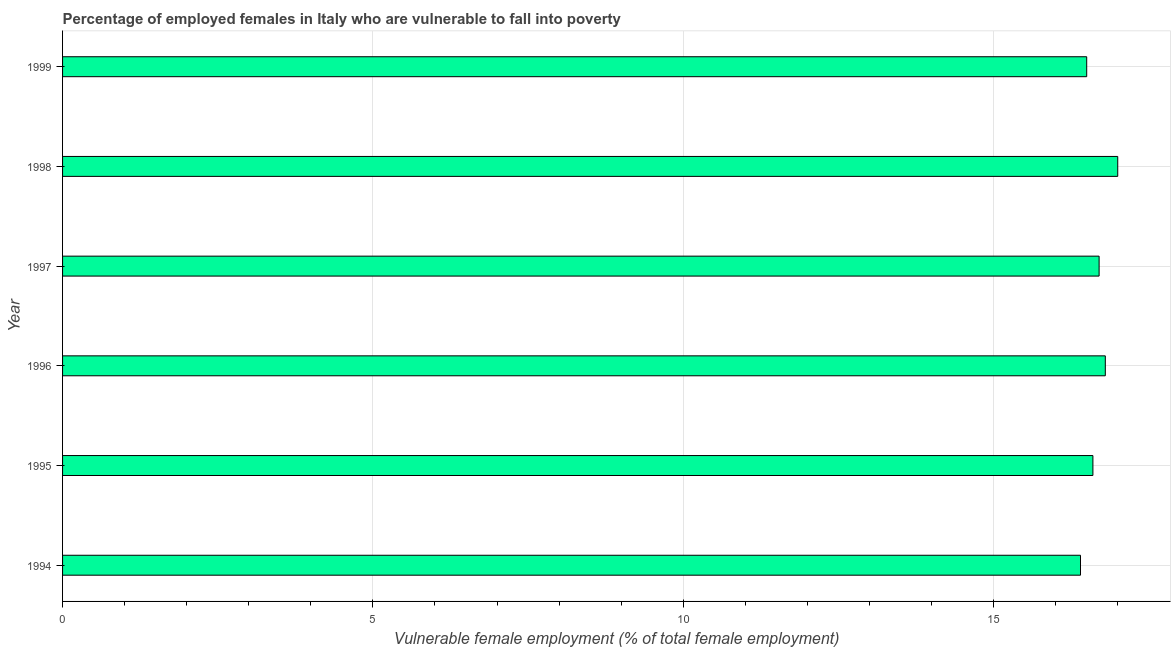What is the title of the graph?
Make the answer very short. Percentage of employed females in Italy who are vulnerable to fall into poverty. What is the label or title of the X-axis?
Your response must be concise. Vulnerable female employment (% of total female employment). What is the label or title of the Y-axis?
Your answer should be very brief. Year. What is the percentage of employed females who are vulnerable to fall into poverty in 1997?
Your answer should be compact. 16.7. Across all years, what is the maximum percentage of employed females who are vulnerable to fall into poverty?
Keep it short and to the point. 17. Across all years, what is the minimum percentage of employed females who are vulnerable to fall into poverty?
Your response must be concise. 16.4. What is the sum of the percentage of employed females who are vulnerable to fall into poverty?
Provide a succinct answer. 100. What is the average percentage of employed females who are vulnerable to fall into poverty per year?
Offer a terse response. 16.67. What is the median percentage of employed females who are vulnerable to fall into poverty?
Give a very brief answer. 16.65. In how many years, is the percentage of employed females who are vulnerable to fall into poverty greater than 12 %?
Provide a short and direct response. 6. Is the difference between the percentage of employed females who are vulnerable to fall into poverty in 1995 and 1999 greater than the difference between any two years?
Make the answer very short. No. What is the difference between the highest and the second highest percentage of employed females who are vulnerable to fall into poverty?
Offer a very short reply. 0.2. What is the difference between the highest and the lowest percentage of employed females who are vulnerable to fall into poverty?
Ensure brevity in your answer.  0.6. In how many years, is the percentage of employed females who are vulnerable to fall into poverty greater than the average percentage of employed females who are vulnerable to fall into poverty taken over all years?
Make the answer very short. 3. What is the difference between two consecutive major ticks on the X-axis?
Provide a short and direct response. 5. What is the Vulnerable female employment (% of total female employment) of 1994?
Offer a terse response. 16.4. What is the Vulnerable female employment (% of total female employment) in 1995?
Your answer should be very brief. 16.6. What is the Vulnerable female employment (% of total female employment) of 1996?
Make the answer very short. 16.8. What is the Vulnerable female employment (% of total female employment) in 1997?
Your response must be concise. 16.7. What is the Vulnerable female employment (% of total female employment) in 1998?
Offer a terse response. 17. What is the difference between the Vulnerable female employment (% of total female employment) in 1994 and 1995?
Provide a succinct answer. -0.2. What is the difference between the Vulnerable female employment (% of total female employment) in 1994 and 1997?
Provide a short and direct response. -0.3. What is the difference between the Vulnerable female employment (% of total female employment) in 1994 and 1998?
Your response must be concise. -0.6. What is the difference between the Vulnerable female employment (% of total female employment) in 1994 and 1999?
Provide a short and direct response. -0.1. What is the difference between the Vulnerable female employment (% of total female employment) in 1995 and 1997?
Make the answer very short. -0.1. What is the difference between the Vulnerable female employment (% of total female employment) in 1996 and 1999?
Provide a succinct answer. 0.3. What is the difference between the Vulnerable female employment (% of total female employment) in 1997 and 1999?
Offer a terse response. 0.2. What is the ratio of the Vulnerable female employment (% of total female employment) in 1994 to that in 1995?
Keep it short and to the point. 0.99. What is the ratio of the Vulnerable female employment (% of total female employment) in 1994 to that in 1996?
Your answer should be compact. 0.98. What is the ratio of the Vulnerable female employment (% of total female employment) in 1994 to that in 1999?
Offer a very short reply. 0.99. What is the ratio of the Vulnerable female employment (% of total female employment) in 1995 to that in 1997?
Your answer should be very brief. 0.99. What is the ratio of the Vulnerable female employment (% of total female employment) in 1995 to that in 1999?
Give a very brief answer. 1.01. What is the ratio of the Vulnerable female employment (% of total female employment) in 1996 to that in 1998?
Offer a terse response. 0.99. What is the ratio of the Vulnerable female employment (% of total female employment) in 1998 to that in 1999?
Your answer should be compact. 1.03. 